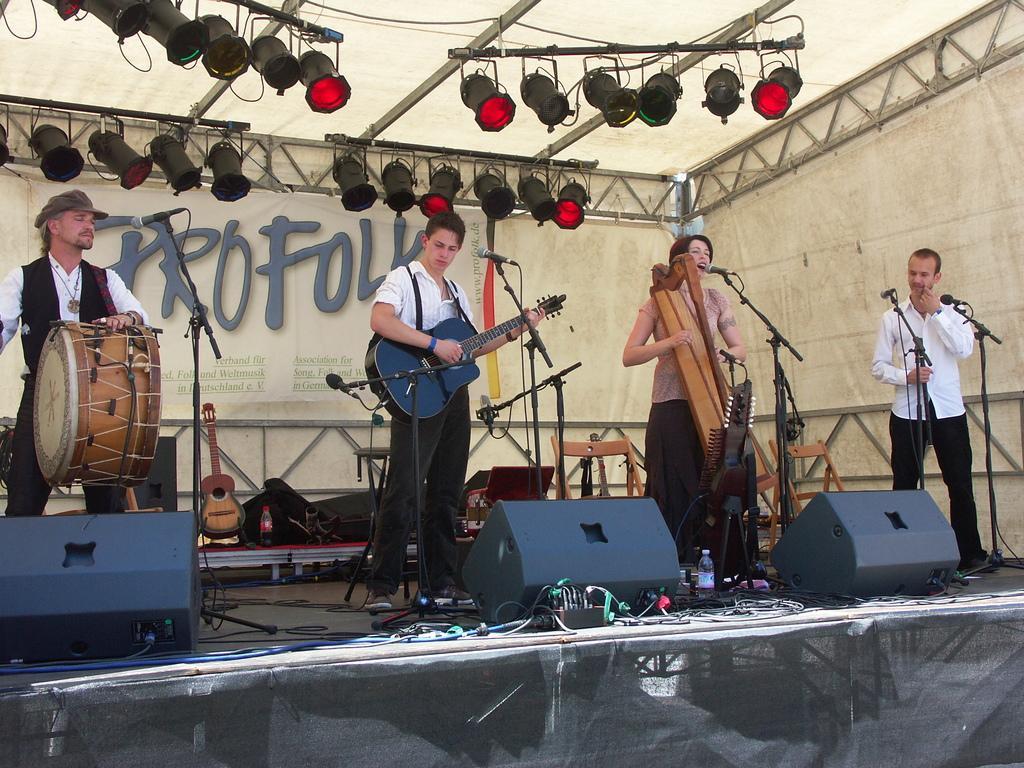How would you summarize this image in a sentence or two? there are four persons standing in front of a microphone and playing musical instrument. 